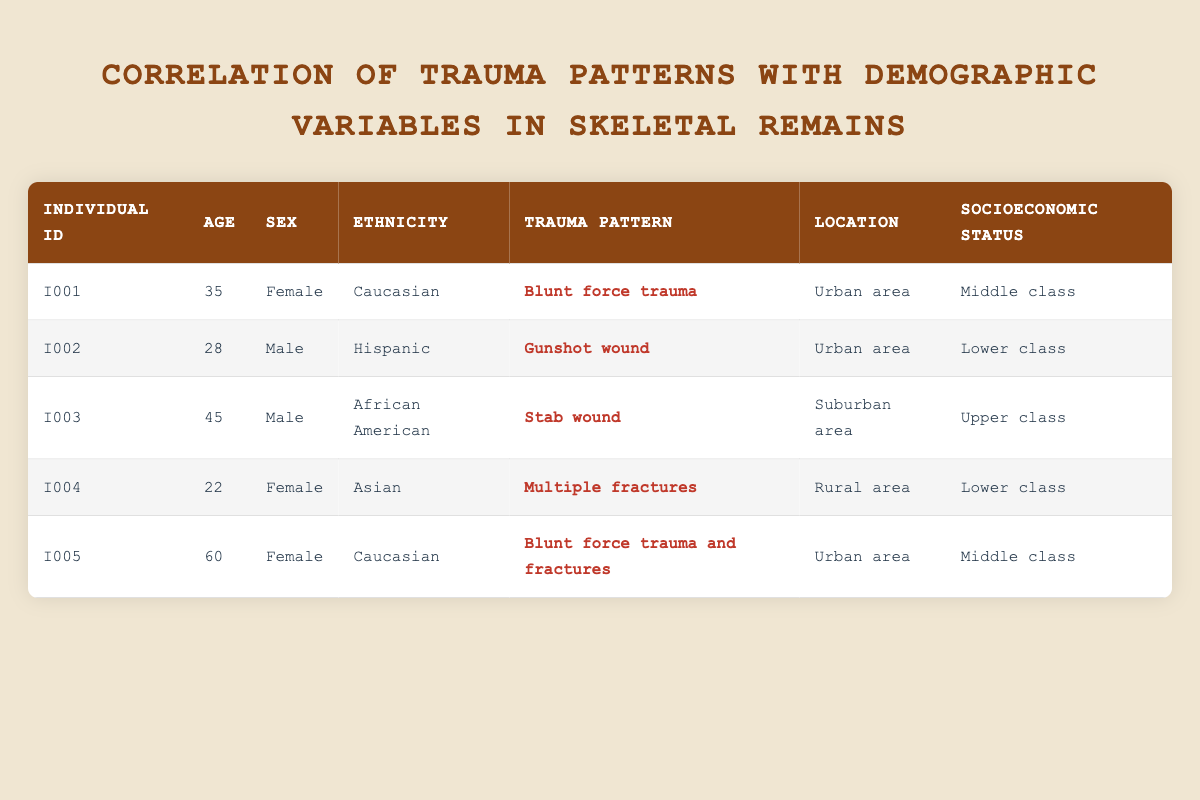What is the trauma pattern associated with individual I001? In the table, I001 appears in the first row, and the trauma pattern is listed as "Blunt force trauma." Therefore, the trauma pattern for individual I001 is as stated.
Answer: Blunt force trauma How many individuals in the table have a socioeconomic status classified as lower class? By checking the socioeconomic status column, we see that individuals I002 and I004 are classified as lower class. Therefore, there are a total of two individuals in this category.
Answer: 2 What is the age of the individual with a stab wound? The trauma pattern "Stab wound" corresponds to individual I003. Looking up this individual's age in the table, we find that I003 is 45 years old.
Answer: 45 Is there any individual in the table who is both female and of Caucasian ethnicity? Upon reviewing the table, individuals I001 and I005 are both female. However, only I001 is categorized as Caucasian. Therefore, the answer to this question is yes, there is an individual matching both criteria.
Answer: Yes What is the average age of individuals who experienced blunt force trauma? First, identify individuals who had a "Blunt force trauma" in the trauma pattern: I001 (35 years old) and I005 (60 years old). Next, sum their ages: 35 + 60 = 95. There are 2 individuals, so to find the average, divide the total by 2: 95 / 2 = 47.5.
Answer: 47.5 How many trauma patterns were observed for individuals from urban areas? The table lists individuals I001, I002, and I005 as being located in urban areas. Their respective trauma patterns are: Blunt force trauma, Gunshot wound, and Blunt force trauma and fractures. Hence, there are three distinct trauma patterns observed for urban residents.
Answer: 3 Is there an individual with multiple fractures? Looking at the trauma pattern column, individual I004 is listed with "Multiple fractures" as their trauma pattern. Thus, there indeed exists an individual with this specific injury type.
Answer: Yes How many males are associated with gunshot wounds? By examining the table, I002 is the only male associated with a gunshot wound. This makes it clear that there is exactly one male related to this type of trauma.
Answer: 1 What is the most common location for the individuals listed in the table? Analyzing the location data, we see that individuals I001, I002, and I005 are located in urban areas while I003 is in a suburban area and I004 is in a rural area. The urban area appears most frequently in the table, which indicates it is the most common location.
Answer: Urban area 